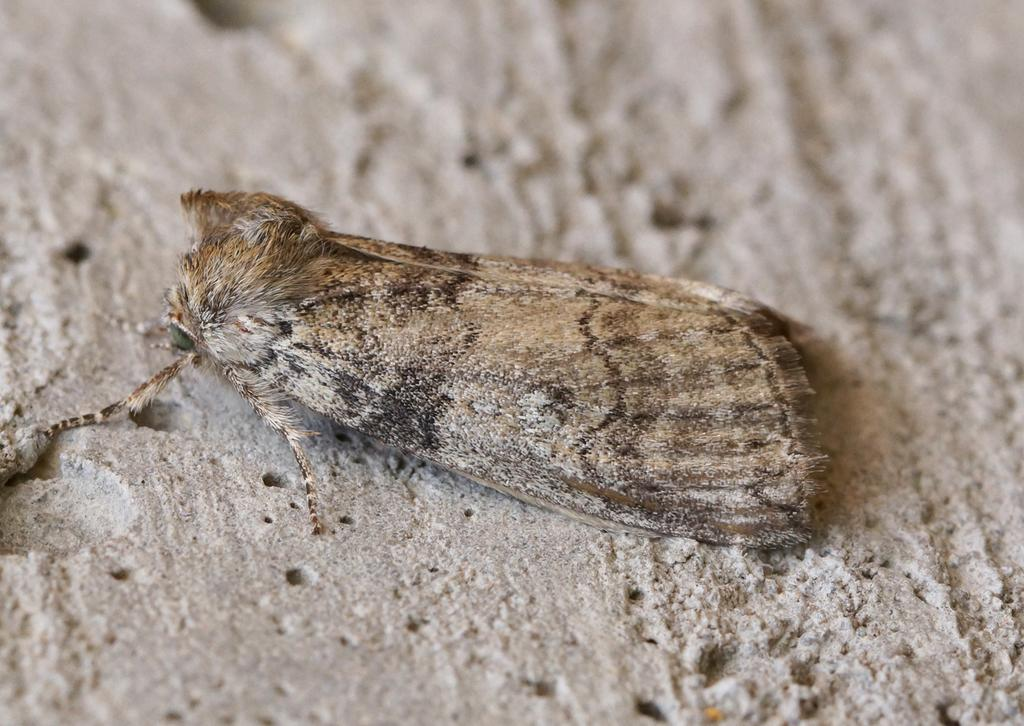What is located on the ground in the foreground of the image? There is an insect on the ground in the foreground of the image. What type of bread can be seen in the image? There is no bread present in the image; it features an insect on the ground. What operation is being performed by the insect in the image? There is no operation being performed by the insect in the image; it is simply located on the ground. 